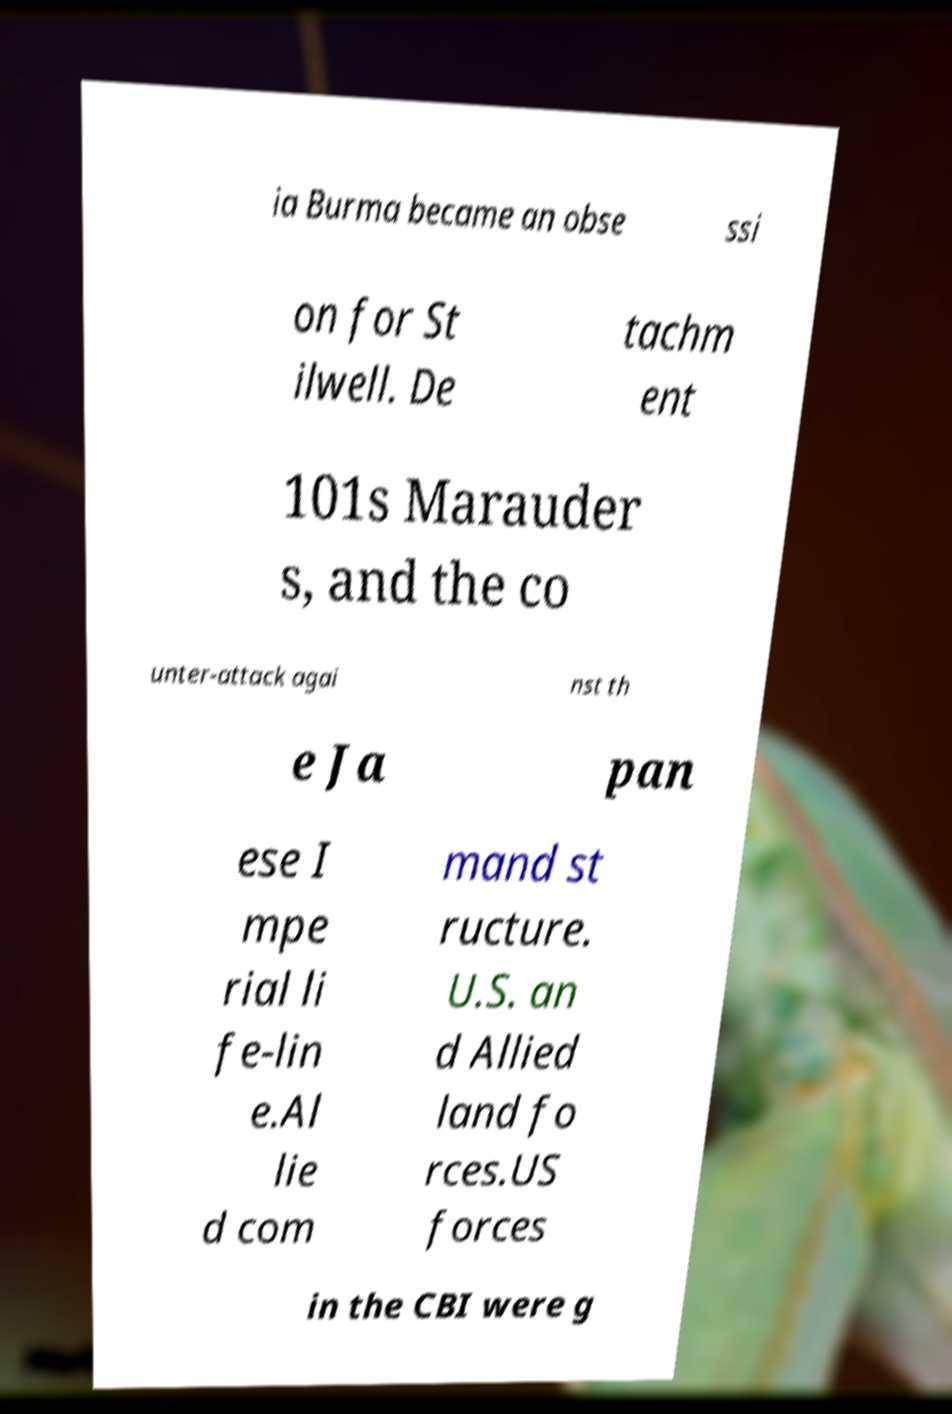Could you extract and type out the text from this image? ia Burma became an obse ssi on for St ilwell. De tachm ent 101s Marauder s, and the co unter-attack agai nst th e Ja pan ese I mpe rial li fe-lin e.Al lie d com mand st ructure. U.S. an d Allied land fo rces.US forces in the CBI were g 